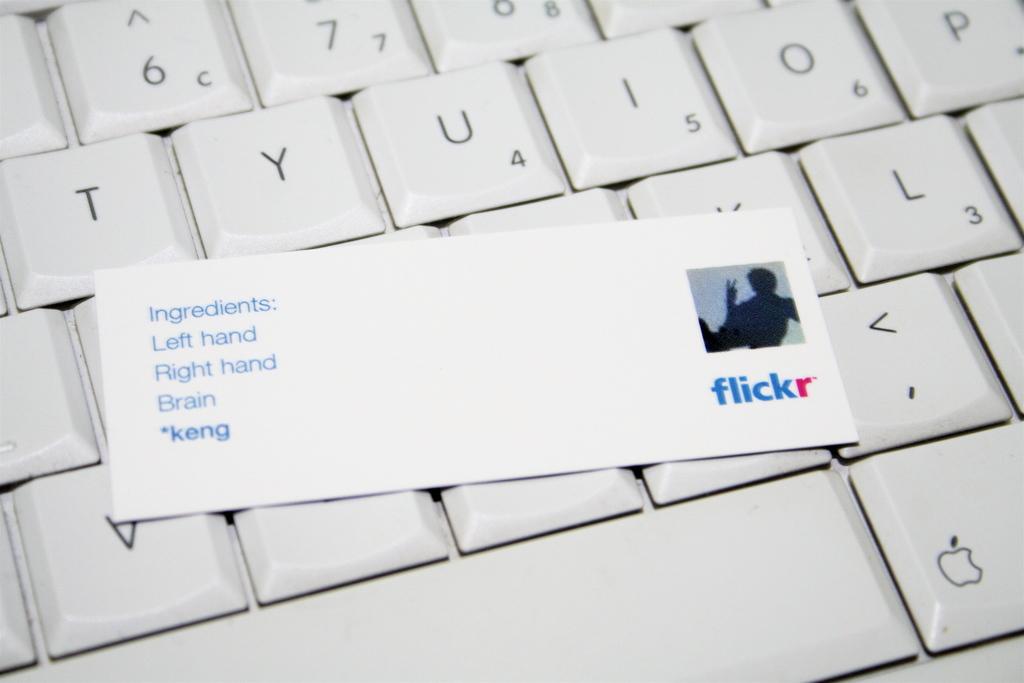What are the ingredients?
Offer a very short reply. Left hand, right hand, brain. What photo sharing site is this card from?
Give a very brief answer. Flickr. 